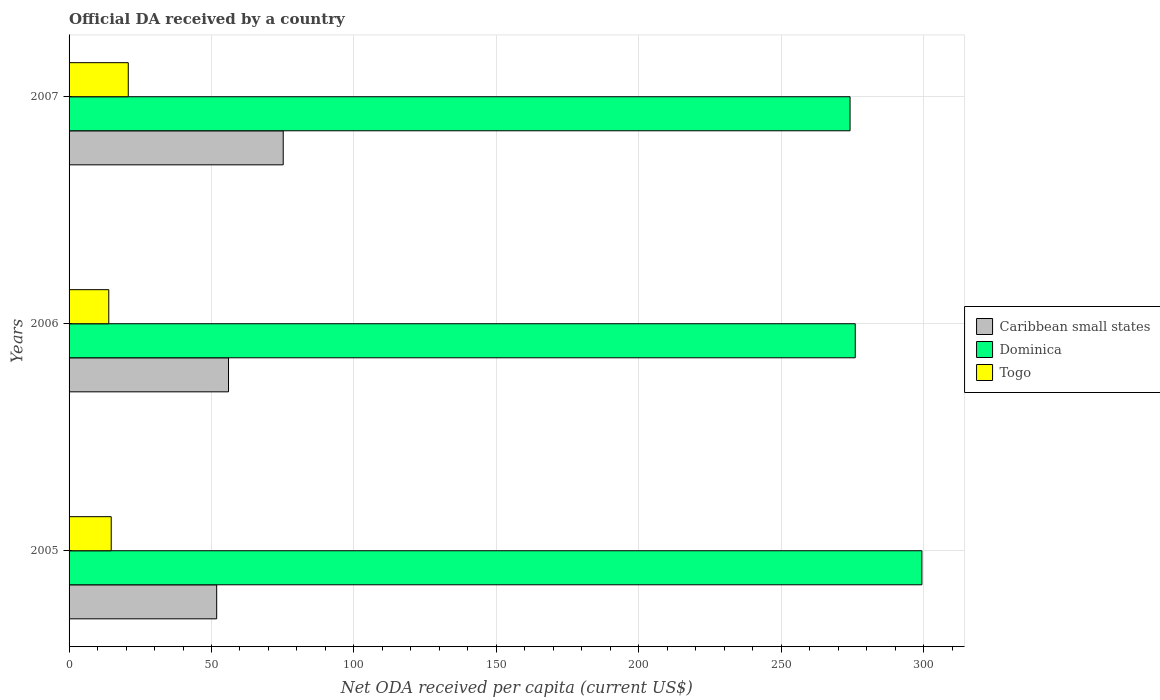How many groups of bars are there?
Give a very brief answer. 3. Are the number of bars on each tick of the Y-axis equal?
Offer a terse response. Yes. How many bars are there on the 2nd tick from the top?
Make the answer very short. 3. How many bars are there on the 3rd tick from the bottom?
Keep it short and to the point. 3. What is the label of the 1st group of bars from the top?
Keep it short and to the point. 2007. What is the ODA received in in Dominica in 2006?
Make the answer very short. 275.99. Across all years, what is the maximum ODA received in in Dominica?
Give a very brief answer. 299.4. Across all years, what is the minimum ODA received in in Dominica?
Give a very brief answer. 274.17. In which year was the ODA received in in Togo maximum?
Provide a succinct answer. 2007. In which year was the ODA received in in Togo minimum?
Your answer should be very brief. 2006. What is the total ODA received in in Caribbean small states in the graph?
Provide a succinct answer. 182.97. What is the difference between the ODA received in in Togo in 2005 and that in 2007?
Make the answer very short. -5.99. What is the difference between the ODA received in in Caribbean small states in 2006 and the ODA received in in Togo in 2007?
Your response must be concise. 35.19. What is the average ODA received in in Dominica per year?
Provide a short and direct response. 283.19. In the year 2007, what is the difference between the ODA received in in Caribbean small states and ODA received in in Togo?
Your answer should be compact. 54.39. What is the ratio of the ODA received in in Caribbean small states in 2005 to that in 2007?
Provide a short and direct response. 0.69. What is the difference between the highest and the second highest ODA received in in Dominica?
Give a very brief answer. 23.4. What is the difference between the highest and the lowest ODA received in in Togo?
Offer a terse response. 6.84. In how many years, is the ODA received in in Caribbean small states greater than the average ODA received in in Caribbean small states taken over all years?
Make the answer very short. 1. Is the sum of the ODA received in in Dominica in 2005 and 2007 greater than the maximum ODA received in in Togo across all years?
Offer a very short reply. Yes. What does the 3rd bar from the top in 2007 represents?
Your response must be concise. Caribbean small states. What does the 3rd bar from the bottom in 2007 represents?
Make the answer very short. Togo. How many bars are there?
Provide a succinct answer. 9. Are all the bars in the graph horizontal?
Your response must be concise. Yes. How many years are there in the graph?
Offer a very short reply. 3. What is the difference between two consecutive major ticks on the X-axis?
Give a very brief answer. 50. Does the graph contain any zero values?
Provide a succinct answer. No. Does the graph contain grids?
Offer a terse response. Yes. Where does the legend appear in the graph?
Your response must be concise. Center right. How many legend labels are there?
Your response must be concise. 3. What is the title of the graph?
Your answer should be compact. Official DA received by a country. What is the label or title of the X-axis?
Your answer should be very brief. Net ODA received per capita (current US$). What is the Net ODA received per capita (current US$) of Caribbean small states in 2005?
Your answer should be very brief. 51.82. What is the Net ODA received per capita (current US$) in Dominica in 2005?
Keep it short and to the point. 299.4. What is the Net ODA received per capita (current US$) in Togo in 2005?
Make the answer very short. 14.8. What is the Net ODA received per capita (current US$) of Caribbean small states in 2006?
Give a very brief answer. 55.97. What is the Net ODA received per capita (current US$) of Dominica in 2006?
Provide a short and direct response. 275.99. What is the Net ODA received per capita (current US$) in Togo in 2006?
Make the answer very short. 13.94. What is the Net ODA received per capita (current US$) of Caribbean small states in 2007?
Provide a succinct answer. 75.18. What is the Net ODA received per capita (current US$) in Dominica in 2007?
Make the answer very short. 274.17. What is the Net ODA received per capita (current US$) of Togo in 2007?
Give a very brief answer. 20.78. Across all years, what is the maximum Net ODA received per capita (current US$) in Caribbean small states?
Provide a succinct answer. 75.18. Across all years, what is the maximum Net ODA received per capita (current US$) of Dominica?
Your answer should be very brief. 299.4. Across all years, what is the maximum Net ODA received per capita (current US$) in Togo?
Keep it short and to the point. 20.78. Across all years, what is the minimum Net ODA received per capita (current US$) in Caribbean small states?
Ensure brevity in your answer.  51.82. Across all years, what is the minimum Net ODA received per capita (current US$) of Dominica?
Provide a short and direct response. 274.17. Across all years, what is the minimum Net ODA received per capita (current US$) of Togo?
Offer a very short reply. 13.94. What is the total Net ODA received per capita (current US$) in Caribbean small states in the graph?
Provide a succinct answer. 182.97. What is the total Net ODA received per capita (current US$) of Dominica in the graph?
Provide a short and direct response. 849.56. What is the total Net ODA received per capita (current US$) in Togo in the graph?
Provide a succinct answer. 49.52. What is the difference between the Net ODA received per capita (current US$) of Caribbean small states in 2005 and that in 2006?
Give a very brief answer. -4.15. What is the difference between the Net ODA received per capita (current US$) of Dominica in 2005 and that in 2006?
Your answer should be very brief. 23.4. What is the difference between the Net ODA received per capita (current US$) of Togo in 2005 and that in 2006?
Give a very brief answer. 0.86. What is the difference between the Net ODA received per capita (current US$) of Caribbean small states in 2005 and that in 2007?
Your answer should be very brief. -23.35. What is the difference between the Net ODA received per capita (current US$) of Dominica in 2005 and that in 2007?
Keep it short and to the point. 25.22. What is the difference between the Net ODA received per capita (current US$) in Togo in 2005 and that in 2007?
Offer a terse response. -5.99. What is the difference between the Net ODA received per capita (current US$) of Caribbean small states in 2006 and that in 2007?
Make the answer very short. -19.2. What is the difference between the Net ODA received per capita (current US$) in Dominica in 2006 and that in 2007?
Your answer should be very brief. 1.82. What is the difference between the Net ODA received per capita (current US$) of Togo in 2006 and that in 2007?
Give a very brief answer. -6.84. What is the difference between the Net ODA received per capita (current US$) of Caribbean small states in 2005 and the Net ODA received per capita (current US$) of Dominica in 2006?
Your response must be concise. -224.17. What is the difference between the Net ODA received per capita (current US$) in Caribbean small states in 2005 and the Net ODA received per capita (current US$) in Togo in 2006?
Offer a terse response. 37.89. What is the difference between the Net ODA received per capita (current US$) of Dominica in 2005 and the Net ODA received per capita (current US$) of Togo in 2006?
Your response must be concise. 285.46. What is the difference between the Net ODA received per capita (current US$) of Caribbean small states in 2005 and the Net ODA received per capita (current US$) of Dominica in 2007?
Offer a terse response. -222.35. What is the difference between the Net ODA received per capita (current US$) of Caribbean small states in 2005 and the Net ODA received per capita (current US$) of Togo in 2007?
Give a very brief answer. 31.04. What is the difference between the Net ODA received per capita (current US$) of Dominica in 2005 and the Net ODA received per capita (current US$) of Togo in 2007?
Your answer should be very brief. 278.61. What is the difference between the Net ODA received per capita (current US$) in Caribbean small states in 2006 and the Net ODA received per capita (current US$) in Dominica in 2007?
Offer a very short reply. -218.2. What is the difference between the Net ODA received per capita (current US$) in Caribbean small states in 2006 and the Net ODA received per capita (current US$) in Togo in 2007?
Offer a terse response. 35.19. What is the difference between the Net ODA received per capita (current US$) of Dominica in 2006 and the Net ODA received per capita (current US$) of Togo in 2007?
Offer a terse response. 255.21. What is the average Net ODA received per capita (current US$) of Caribbean small states per year?
Your response must be concise. 60.99. What is the average Net ODA received per capita (current US$) of Dominica per year?
Keep it short and to the point. 283.19. What is the average Net ODA received per capita (current US$) of Togo per year?
Provide a succinct answer. 16.51. In the year 2005, what is the difference between the Net ODA received per capita (current US$) of Caribbean small states and Net ODA received per capita (current US$) of Dominica?
Offer a terse response. -247.57. In the year 2005, what is the difference between the Net ODA received per capita (current US$) of Caribbean small states and Net ODA received per capita (current US$) of Togo?
Provide a succinct answer. 37.03. In the year 2005, what is the difference between the Net ODA received per capita (current US$) in Dominica and Net ODA received per capita (current US$) in Togo?
Your response must be concise. 284.6. In the year 2006, what is the difference between the Net ODA received per capita (current US$) of Caribbean small states and Net ODA received per capita (current US$) of Dominica?
Offer a very short reply. -220.02. In the year 2006, what is the difference between the Net ODA received per capita (current US$) of Caribbean small states and Net ODA received per capita (current US$) of Togo?
Your response must be concise. 42.03. In the year 2006, what is the difference between the Net ODA received per capita (current US$) of Dominica and Net ODA received per capita (current US$) of Togo?
Offer a terse response. 262.05. In the year 2007, what is the difference between the Net ODA received per capita (current US$) in Caribbean small states and Net ODA received per capita (current US$) in Dominica?
Your answer should be very brief. -199. In the year 2007, what is the difference between the Net ODA received per capita (current US$) of Caribbean small states and Net ODA received per capita (current US$) of Togo?
Provide a short and direct response. 54.39. In the year 2007, what is the difference between the Net ODA received per capita (current US$) in Dominica and Net ODA received per capita (current US$) in Togo?
Make the answer very short. 253.39. What is the ratio of the Net ODA received per capita (current US$) of Caribbean small states in 2005 to that in 2006?
Offer a very short reply. 0.93. What is the ratio of the Net ODA received per capita (current US$) in Dominica in 2005 to that in 2006?
Make the answer very short. 1.08. What is the ratio of the Net ODA received per capita (current US$) in Togo in 2005 to that in 2006?
Provide a short and direct response. 1.06. What is the ratio of the Net ODA received per capita (current US$) of Caribbean small states in 2005 to that in 2007?
Provide a short and direct response. 0.69. What is the ratio of the Net ODA received per capita (current US$) in Dominica in 2005 to that in 2007?
Keep it short and to the point. 1.09. What is the ratio of the Net ODA received per capita (current US$) in Togo in 2005 to that in 2007?
Your answer should be compact. 0.71. What is the ratio of the Net ODA received per capita (current US$) of Caribbean small states in 2006 to that in 2007?
Offer a very short reply. 0.74. What is the ratio of the Net ODA received per capita (current US$) in Dominica in 2006 to that in 2007?
Offer a very short reply. 1.01. What is the ratio of the Net ODA received per capita (current US$) of Togo in 2006 to that in 2007?
Offer a terse response. 0.67. What is the difference between the highest and the second highest Net ODA received per capita (current US$) of Caribbean small states?
Make the answer very short. 19.2. What is the difference between the highest and the second highest Net ODA received per capita (current US$) of Dominica?
Your answer should be compact. 23.4. What is the difference between the highest and the second highest Net ODA received per capita (current US$) of Togo?
Provide a succinct answer. 5.99. What is the difference between the highest and the lowest Net ODA received per capita (current US$) in Caribbean small states?
Offer a very short reply. 23.35. What is the difference between the highest and the lowest Net ODA received per capita (current US$) in Dominica?
Ensure brevity in your answer.  25.22. What is the difference between the highest and the lowest Net ODA received per capita (current US$) of Togo?
Offer a very short reply. 6.84. 